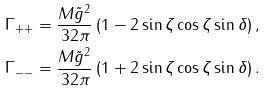Convert formula to latex. <formula><loc_0><loc_0><loc_500><loc_500>\Gamma _ { + + } & = \frac { M \tilde { g } ^ { 2 } } { 3 2 \pi } \left ( 1 - 2 \sin { \zeta } \cos { \zeta } \sin { \delta } \right ) , \\ \Gamma _ { - - } & = \frac { M \tilde { g } ^ { 2 } } { 3 2 \pi } \left ( 1 + 2 \sin { \zeta } \cos { \zeta } \sin { \delta } \right ) .</formula> 